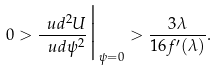<formula> <loc_0><loc_0><loc_500><loc_500>0 > \frac { \ u d ^ { 2 } U } { \ u d \psi ^ { 2 } } \Big | _ { \psi = 0 } > \frac { 3 \lambda } { 1 6 f ^ { \prime } ( \lambda ) } .</formula> 